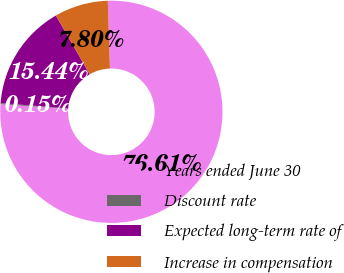Convert chart to OTSL. <chart><loc_0><loc_0><loc_500><loc_500><pie_chart><fcel>Years ended June 30<fcel>Discount rate<fcel>Expected long-term rate of<fcel>Increase in compensation<nl><fcel>76.61%<fcel>0.15%<fcel>15.44%<fcel>7.8%<nl></chart> 